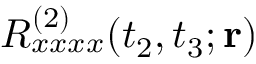<formula> <loc_0><loc_0><loc_500><loc_500>R _ { x x x x } ^ { ( 2 ) } ( t _ { 2 } , t _ { 3 } ; { r } )</formula> 